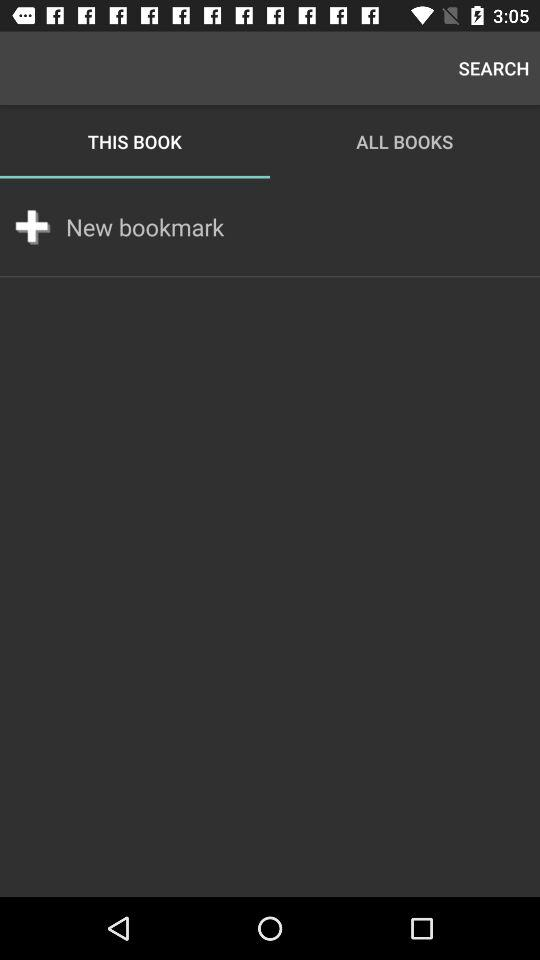Which tab is selected? The selected tab is "THIS BOOK". 